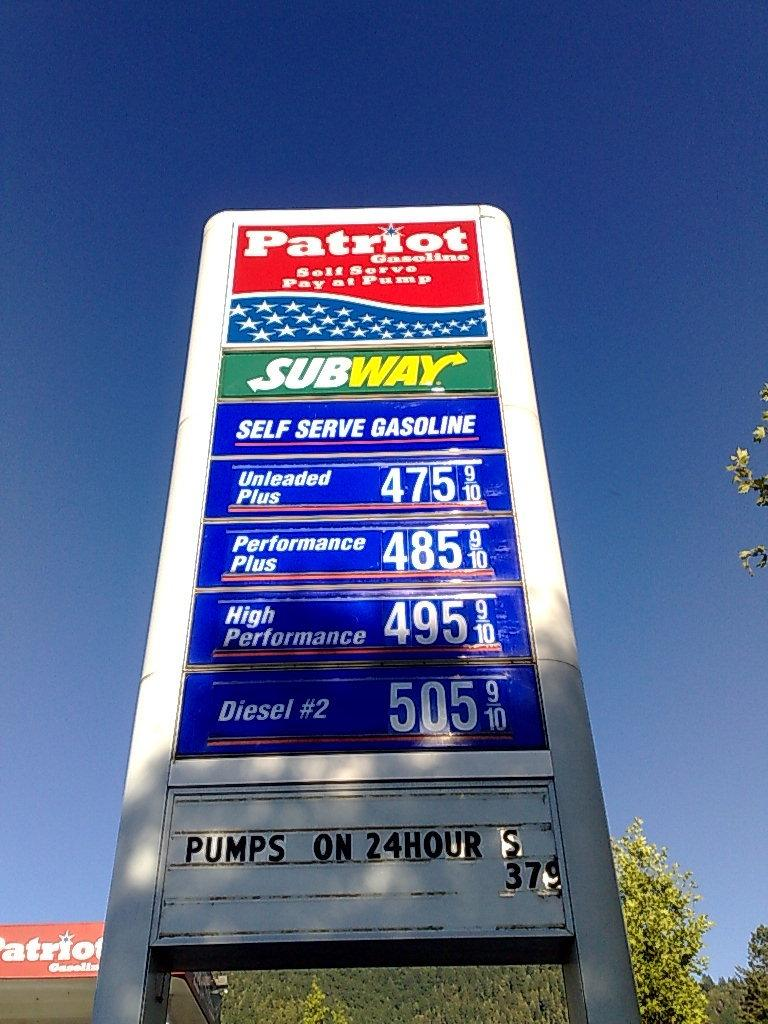<image>
Relay a brief, clear account of the picture shown. the billboard for a patriot gas station with a subway logo on the bottom. 